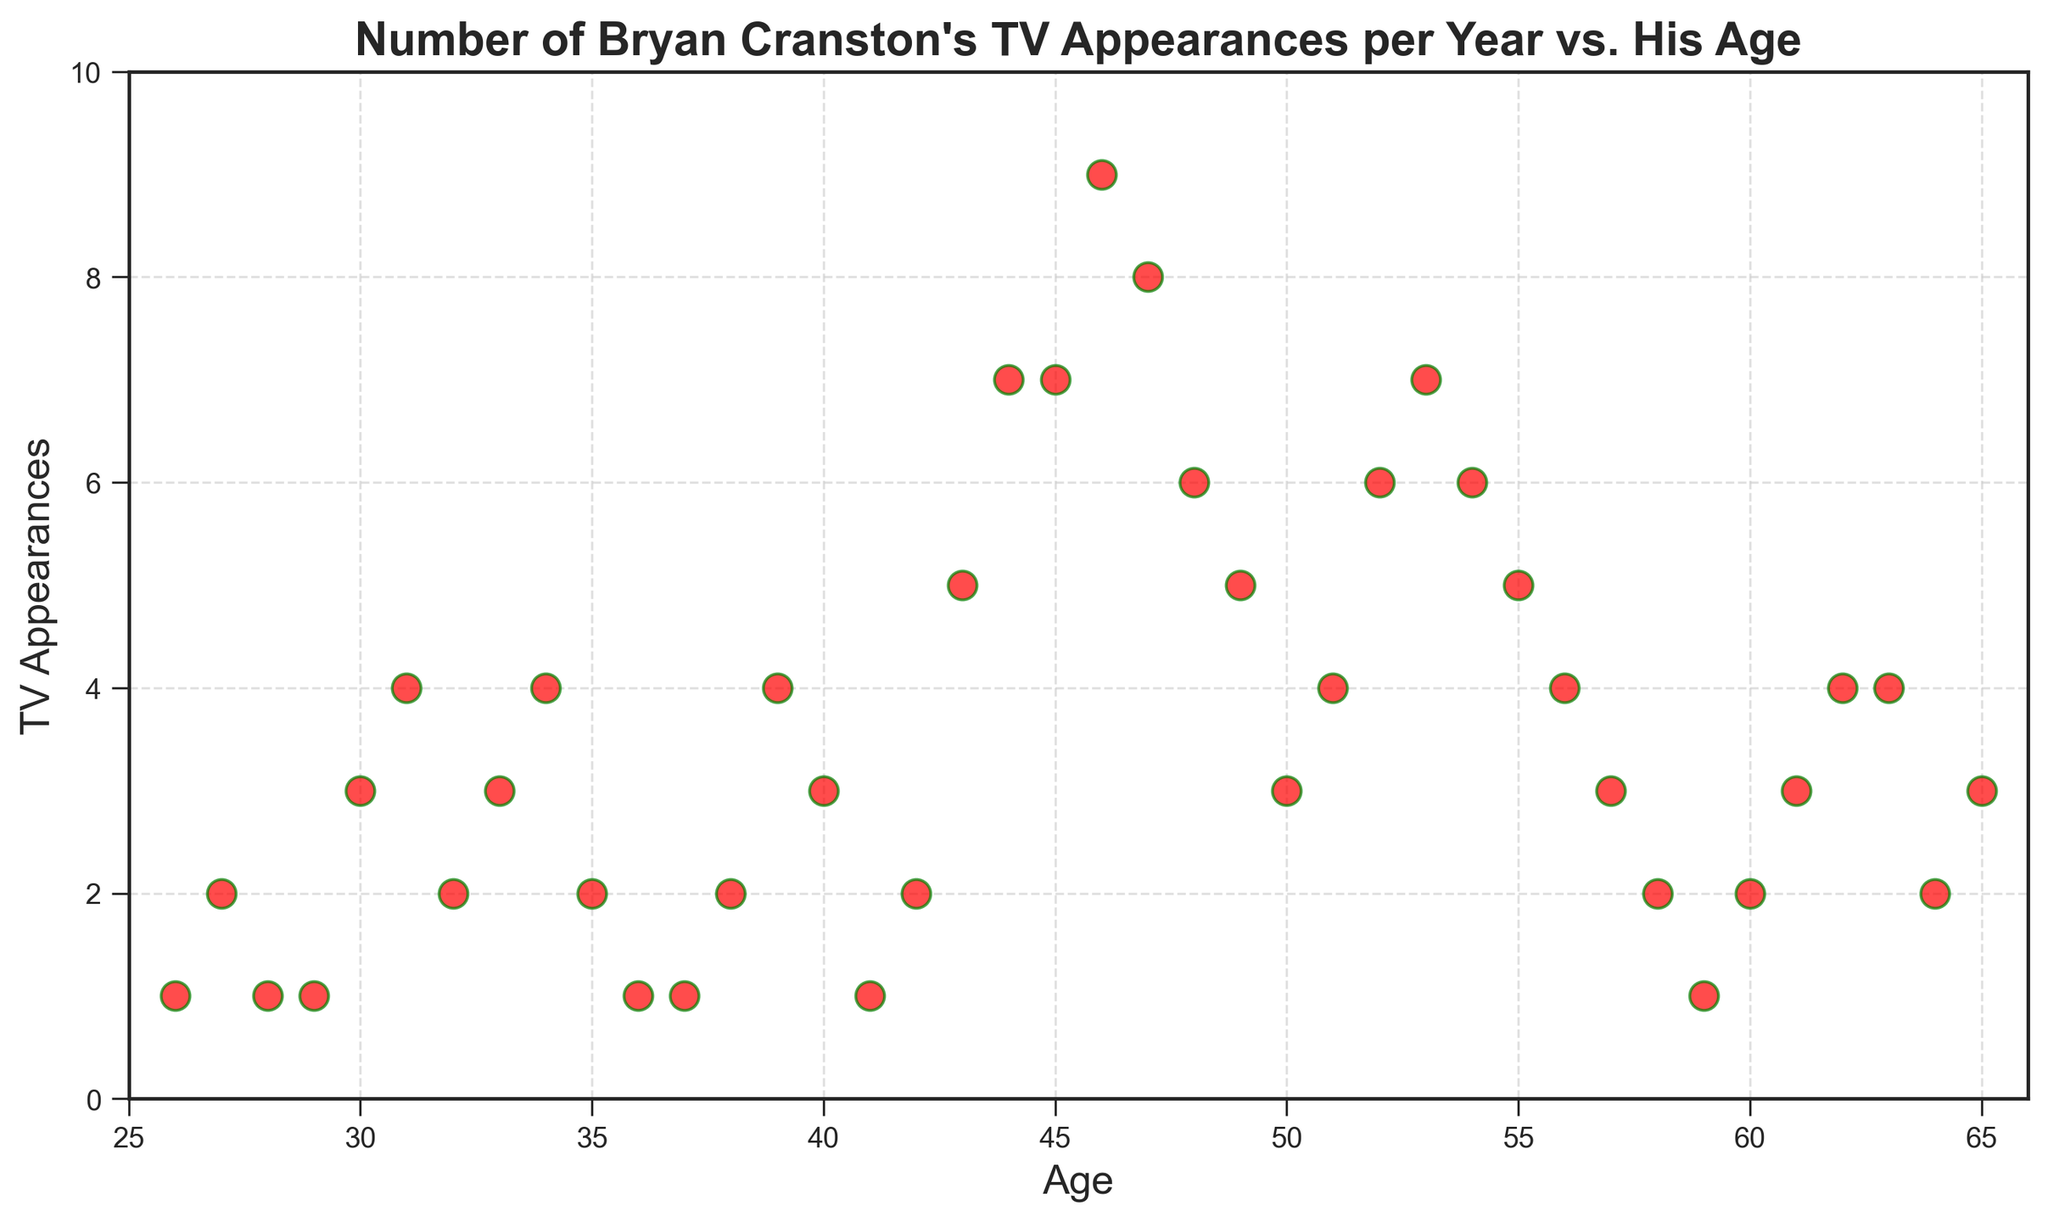What is the maximum number of TV appearances Bryan Cranston made in a year, and at what age? To find the maximum number of TV appearances, look for the highest point on the vertical axis representing TV Appearances. The highest point is at 9 appearances, which occurs when Bryan is 46 years old.
Answer: 9 appearances, age 46 During which age span did Bryan Cranston see the most significant increase in TV appearances? To observe the most significant increase, compare the slope between consecutive points. The steepest slope appears between ages 43 and 46, where TV appearances jumped from 5 to 9.
Answer: From age 43 to 46 During which age span did Bryan Cranston's TV appearances decrease the most? Identify the steepest downward slope between consecutive points. The most significant decrease occurs from age 47 (with 8 appearances) to age 48 (with 6 appearances), a drop of 2 appearances.
Answer: From age 47 to 48 How many years did Bryan Cranston make exactly 6 TV appearances? Count the number of points aligned with the 6 appearances mark on the vertical axis. He made 6 appearances in 3 different years.
Answer: 3 years Did Bryan Cranston ever have a year with no TV appearances, according to the plot? Check if there's any point representing 0 appearances on the vertical axis. The plot does not show any point at 0, so he had at least 1 appearance every year in the dataset.
Answer: No How many years did Bryan Cranston make more than 5 TV appearances? Count the number of points that lie above the 5 appearances mark on the vertical axis. There are 11 points above this threshold.
Answer: 11 years What is the general trend in Bryan Cranston's TV appearances as he ages from 26 to 65? Observe the overall pattern of the points from age 26 to 65. The general trend shows an increase in the number of TV appearances during his middle age, peaking around his mid-40s, followed by a gradual decline towards his later years.
Answer: Increase to peak in mid-40s, then decline What is the average number of TV appearances Bryan Cranston made annually between the ages of 40 and 50? Calculate the mean of TV appearances for ages 40 to 50. Total appearances between these ages = 3 + 1 + 2 + 5 + 7 + 7 + 9 + 8 + 6 + 5 + 3 = 56. Divide by the number of years (11): 56 / 11 ≈ 5.1
Answer: 5.1 How many times did Bryan Cranston make fewer TV appearances in a year than the previous year? Look for points where the TV appearances decrease compared to the adjacent previous year. This happens in 12 instances.
Answer: 12 times 